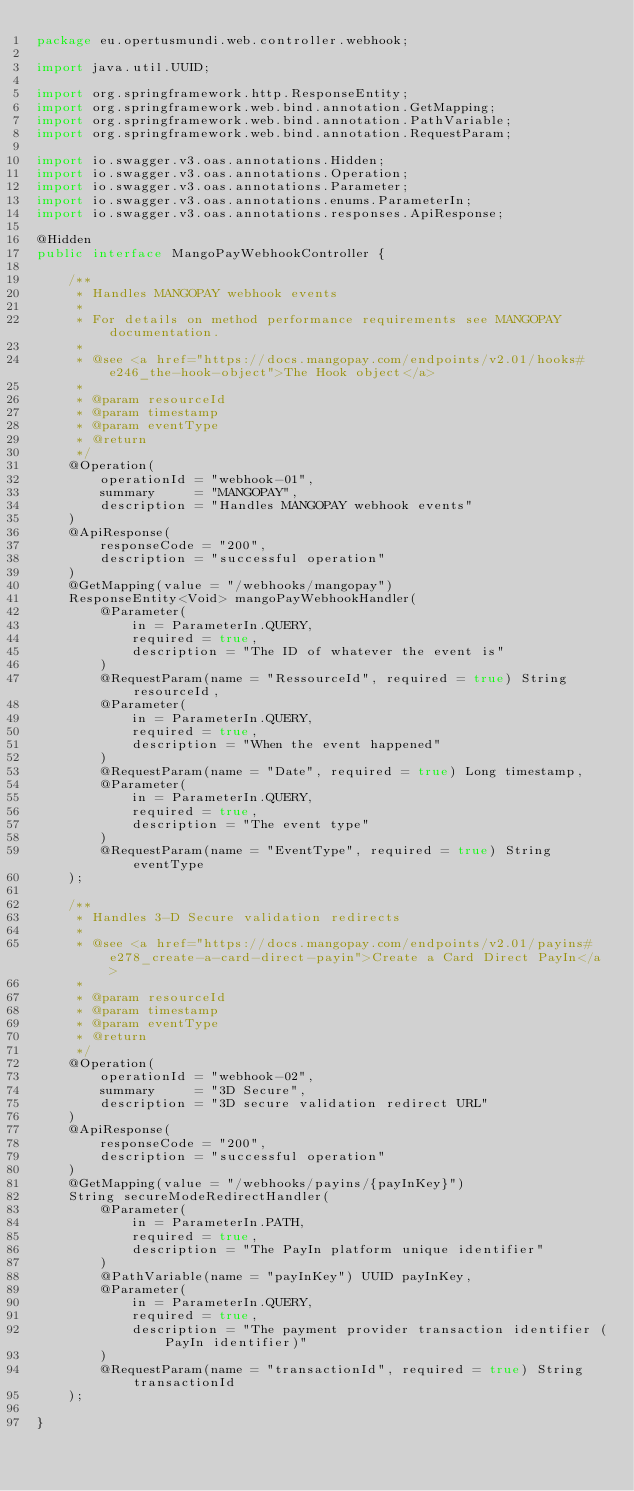Convert code to text. <code><loc_0><loc_0><loc_500><loc_500><_Java_>package eu.opertusmundi.web.controller.webhook;

import java.util.UUID;

import org.springframework.http.ResponseEntity;
import org.springframework.web.bind.annotation.GetMapping;
import org.springframework.web.bind.annotation.PathVariable;
import org.springframework.web.bind.annotation.RequestParam;

import io.swagger.v3.oas.annotations.Hidden;
import io.swagger.v3.oas.annotations.Operation;
import io.swagger.v3.oas.annotations.Parameter;
import io.swagger.v3.oas.annotations.enums.ParameterIn;
import io.swagger.v3.oas.annotations.responses.ApiResponse;

@Hidden
public interface MangoPayWebhookController {

    /**
     * Handles MANGOPAY webhook events
     *
     * For details on method performance requirements see MANGOPAY documentation.
     *
     * @see <a href="https://docs.mangopay.com/endpoints/v2.01/hooks#e246_the-hook-object">The Hook object</a>
     *
     * @param resourceId
     * @param timestamp
     * @param eventType
     * @return
     */
    @Operation(
        operationId = "webhook-01",
        summary     = "MANGOPAY",
        description = "Handles MANGOPAY webhook events"
    )
    @ApiResponse(
        responseCode = "200",
        description = "successful operation"
    )
    @GetMapping(value = "/webhooks/mangopay")
    ResponseEntity<Void> mangoPayWebhookHandler(
        @Parameter(
            in = ParameterIn.QUERY,
            required = true,
            description = "The ID of whatever the event is"
        )
        @RequestParam(name = "RessourceId", required = true) String resourceId,
        @Parameter(
            in = ParameterIn.QUERY,
            required = true,
            description = "When the event happened"
        )
        @RequestParam(name = "Date", required = true) Long timestamp,
        @Parameter(
            in = ParameterIn.QUERY,
            required = true,
            description = "The event type"
        )
        @RequestParam(name = "EventType", required = true) String eventType
    );

    /**
     * Handles 3-D Secure validation redirects
     *
     * @see <a href="https://docs.mangopay.com/endpoints/v2.01/payins#e278_create-a-card-direct-payin">Create a Card Direct PayIn</a>
     *
     * @param resourceId
     * @param timestamp
     * @param eventType
     * @return
     */
    @Operation(
        operationId = "webhook-02",
        summary     = "3D Secure",
        description = "3D secure validation redirect URL"
    )
    @ApiResponse(
        responseCode = "200",
        description = "successful operation"
    )
    @GetMapping(value = "/webhooks/payins/{payInKey}")
    String secureModeRedirectHandler(
        @Parameter(
            in = ParameterIn.PATH,
            required = true,
            description = "The PayIn platform unique identifier"
        )
        @PathVariable(name = "payInKey") UUID payInKey,
        @Parameter(
            in = ParameterIn.QUERY,
            required = true,
            description = "The payment provider transaction identifier (PayIn identifier)"
        )
        @RequestParam(name = "transactionId", required = true) String transactionId
    );

}
</code> 